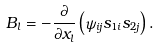Convert formula to latex. <formula><loc_0><loc_0><loc_500><loc_500>B _ { l } = - \frac { \partial } { \partial x _ { l } } \left ( \psi _ { i j } s _ { 1 i } s _ { 2 j } \right ) .</formula> 